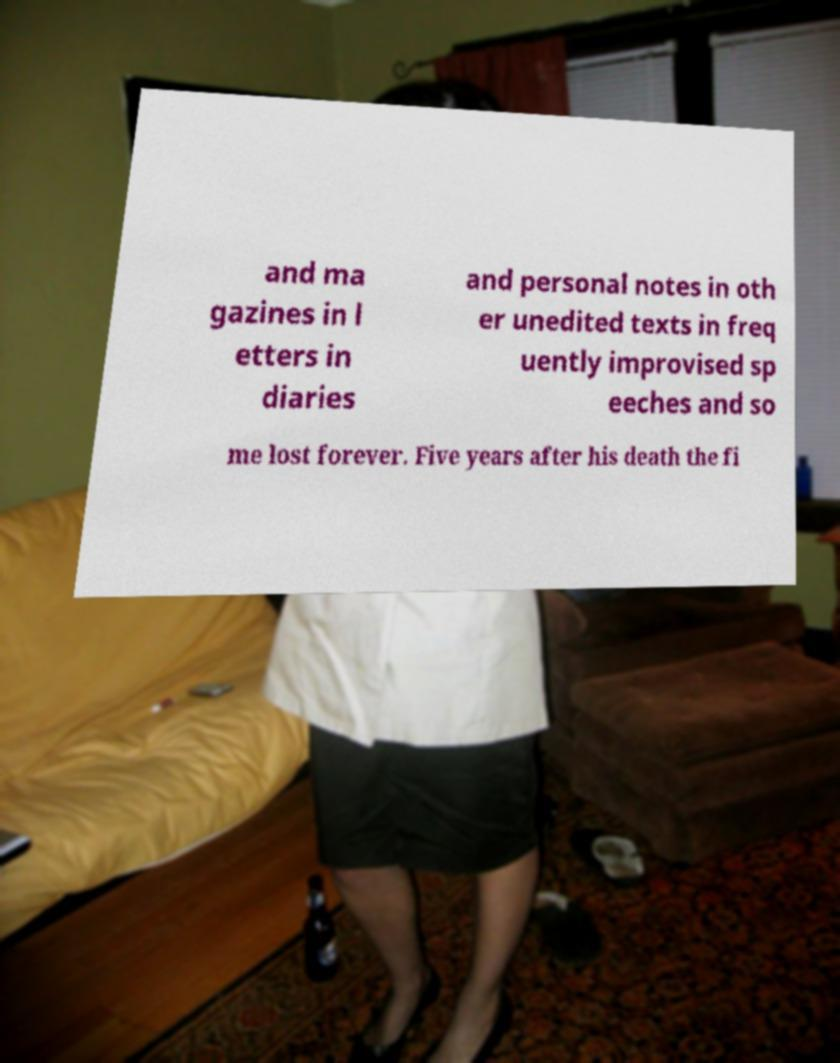Could you extract and type out the text from this image? and ma gazines in l etters in diaries and personal notes in oth er unedited texts in freq uently improvised sp eeches and so me lost forever. Five years after his death the fi 